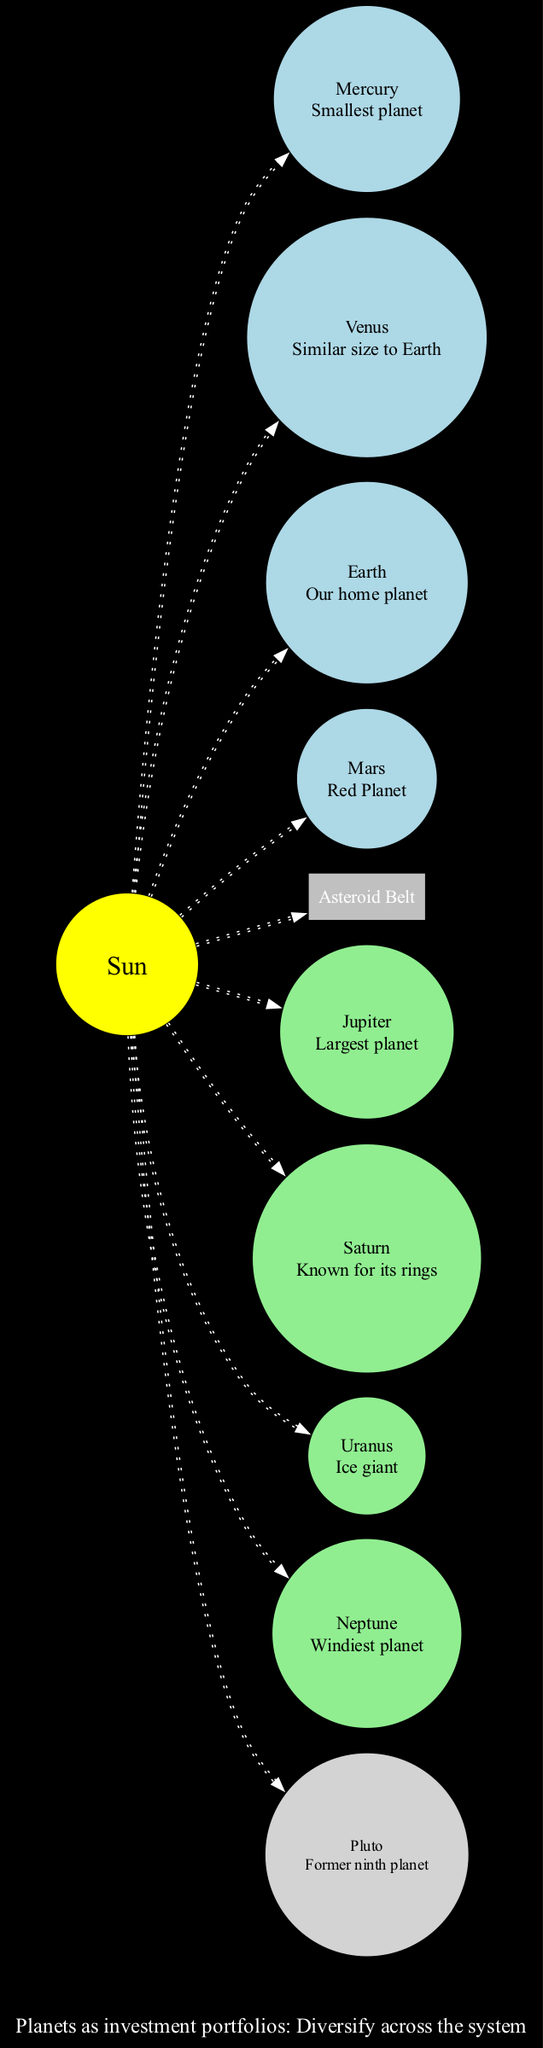What is the name of the central body in the solar system? The central body in the diagram is labeled as "Sun," which is the primary gravitational force for the solar system.
Answer: Sun How many inner planets are there in the solar system diagram? The diagram lists four inner planets: Mercury, Venus, Earth, and Mars, which can be counted directly from the inner planets section.
Answer: 4 What is the fourth planet from the Sun? The inner planets section lists Mars as the fourth planet from the Sun, following Mercury, Venus, and Earth in order.
Answer: Mars Where is the asteroid belt located? The diagram indicates that the asteroid belt is situated between Mars and Jupiter, specifically noted in the astroid belt label.
Answer: Between Mars and Jupiter Which planet is known for its rings? Saturn is highlighted in the outer planets section, with the note "Known for its rings," making it identifiable as the planet associated with rings.
Answer: Saturn What is the last celestial body shown in this diagram? The diagram includes Pluto as the last celestial body beyond Neptune, where it is explicitly mentioned as the dwarf planet.
Answer: Pluto How is the Sun connected to the planets? The diagram shows that each planet is connected to the Sun with dotted lines, illustrating their orbits around it. This indicates a gravitational relationship where the Sun acts as the center of the solar system.
Answer: Dotted lines Which planet is the largest in the solar system? Jupiter is indicated as the largest planet in the outer planets section, as noted by its description "Largest planet."
Answer: Jupiter What financial metaphor is represented in the diagram? The diagram includes a financial metaphor stating that "Planets as investment portfolios: Diversify across the system," which conveys the idea of diversifying investments.
Answer: Diversify across the system 